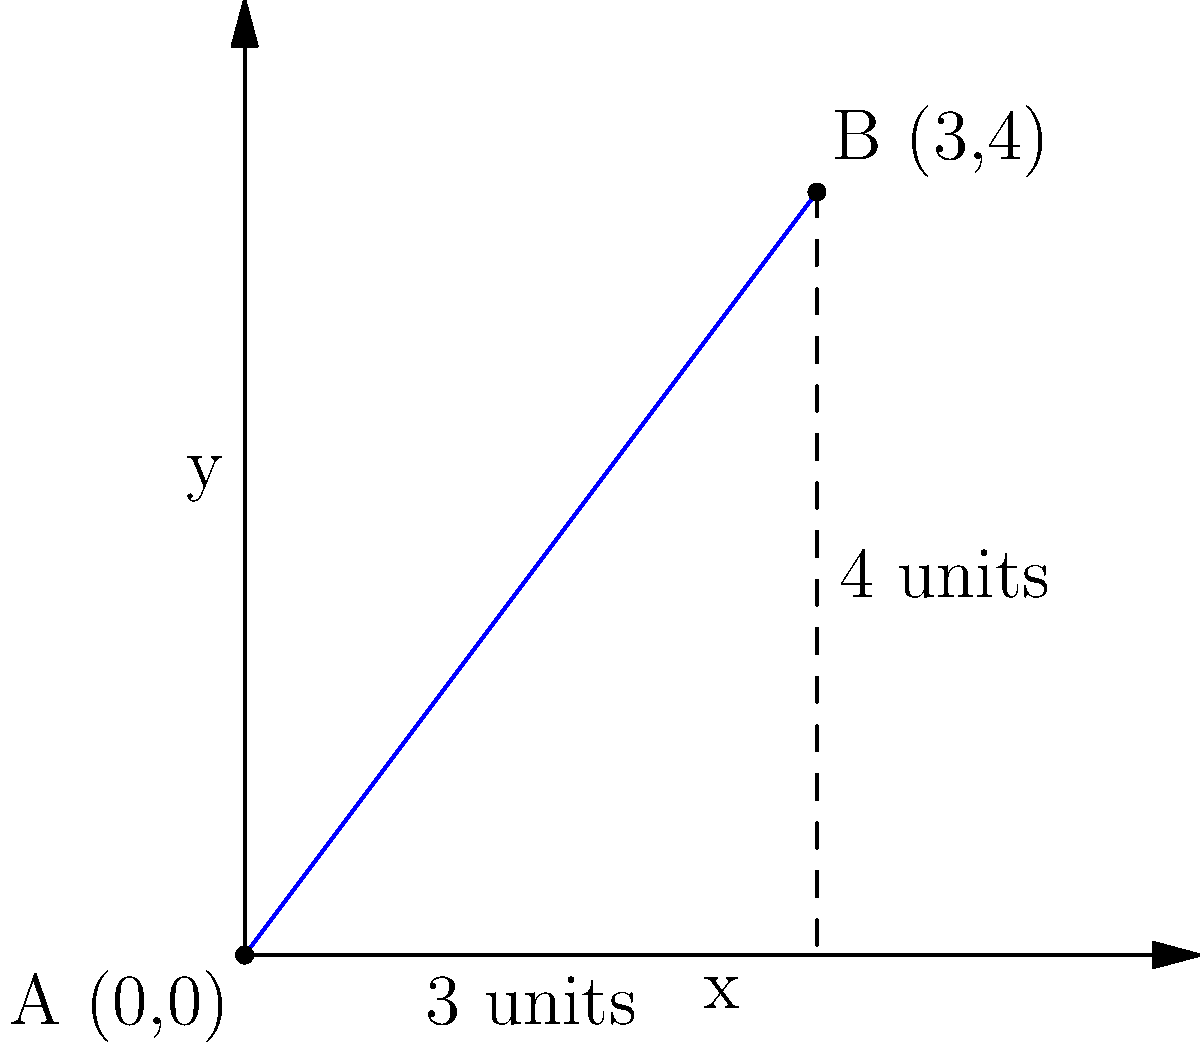As a combat veteran authenticating war relics, you need to verify the location of a reported artifact discovery. You're given two map coordinates: Point A (0,0) and Point B (3,4), where each unit represents 1 kilometer. Using the Pythagorean theorem, calculate the straight-line distance between these two points. What is the distance in kilometers? To solve this problem, we'll use the Pythagorean theorem, which states that in a right triangle, the square of the length of the hypotenuse is equal to the sum of squares of the other two sides.

Step 1: Identify the components of the right triangle.
- The horizontal distance (x-axis) between A and B is 3 units.
- The vertical distance (y-axis) between A and B is 4 units.
- The straight-line distance we're seeking is the hypotenuse of this right triangle.

Step 2: Apply the Pythagorean theorem.
Let c be the hypotenuse (our answer).
$$ c^2 = 3^2 + 4^2 $$

Step 3: Solve the equation.
$$ c^2 = 9 + 16 = 25 $$

Step 4: Take the square root of both sides.
$$ c = \sqrt{25} = 5 $$

Step 5: Interpret the result.
Since each unit represents 1 kilometer, the straight-line distance between points A and B is 5 kilometers.
Answer: 5 km 